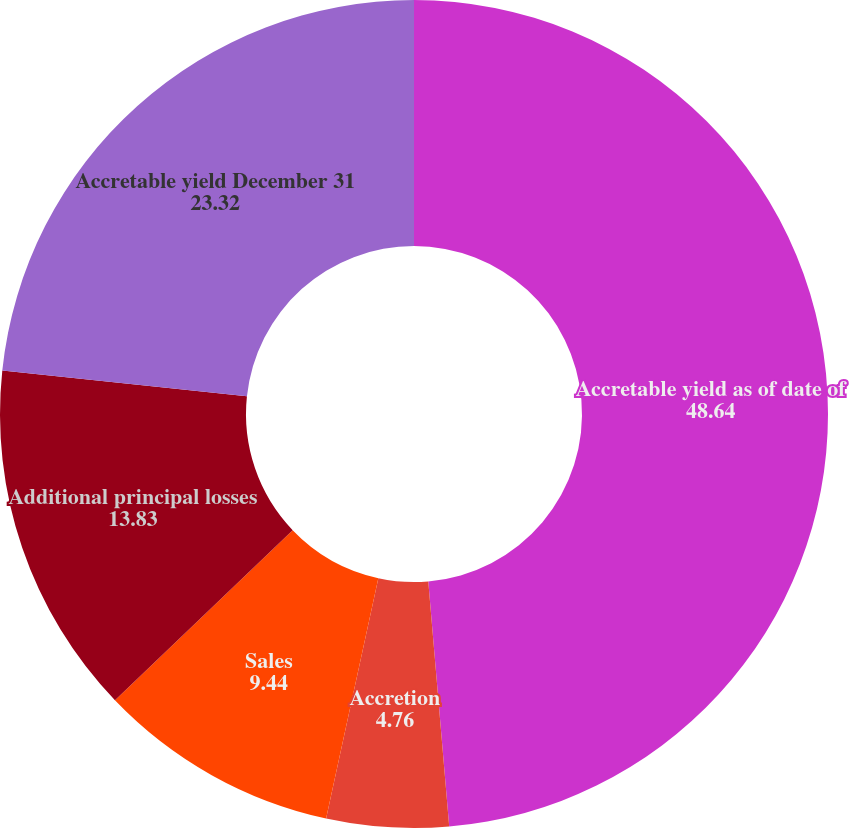Convert chart. <chart><loc_0><loc_0><loc_500><loc_500><pie_chart><fcel>Accretable yield as of date of<fcel>Accretion<fcel>Sales<fcel>Additional principal losses<fcel>Accretable yield December 31<nl><fcel>48.64%<fcel>4.76%<fcel>9.44%<fcel>13.83%<fcel>23.32%<nl></chart> 